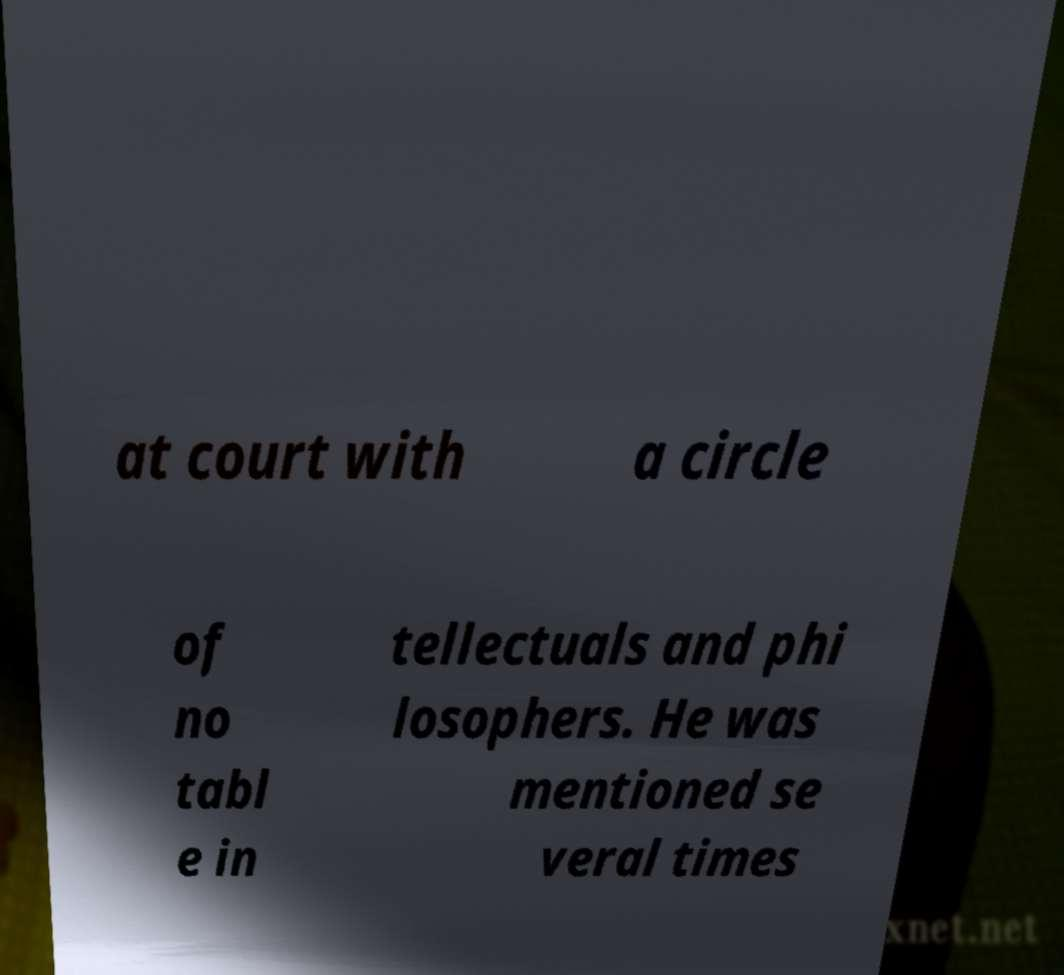I need the written content from this picture converted into text. Can you do that? at court with a circle of no tabl e in tellectuals and phi losophers. He was mentioned se veral times 